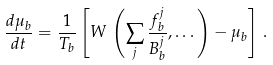Convert formula to latex. <formula><loc_0><loc_0><loc_500><loc_500>\frac { d \mu _ { b } } { d t } = \frac { 1 } { T _ { b } } \left [ W \, \left ( \sum _ { j } \frac { f _ { b } ^ { j } } { B _ { b } ^ { j } } , \dots \right ) - \mu _ { b } \right ] \, .</formula> 